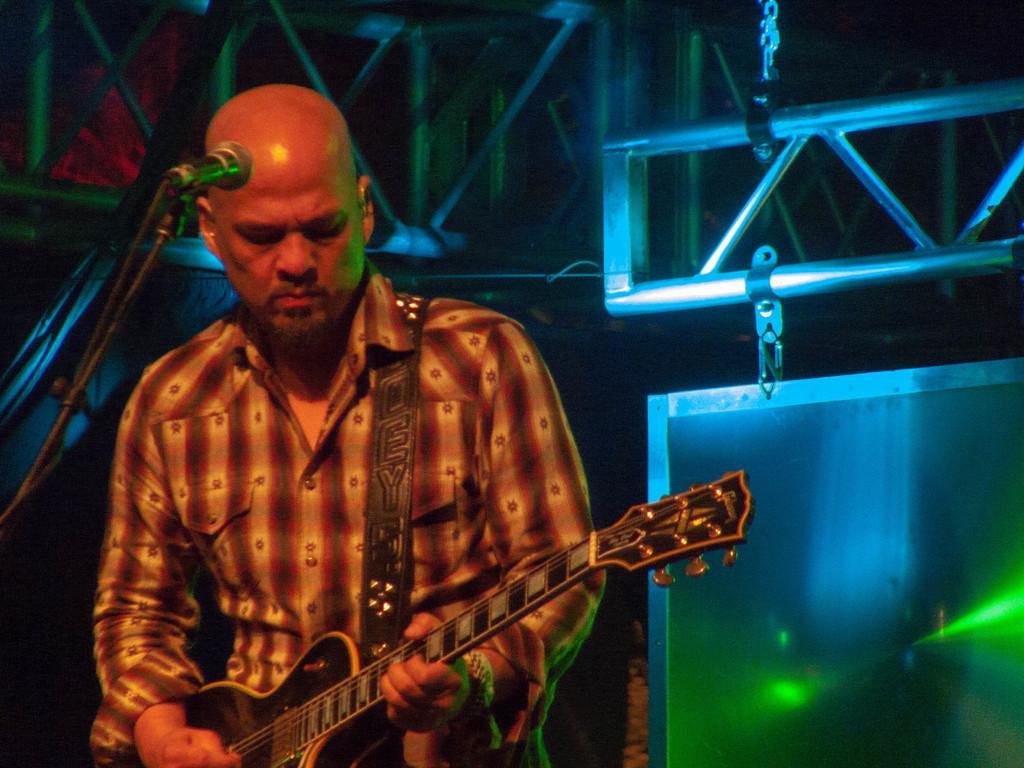Describe this image in one or two sentences. Here is a man standing and playing guitar. This is the mic attached to the mike stand. At background I can see some object hanging,this looks like a metal object. 